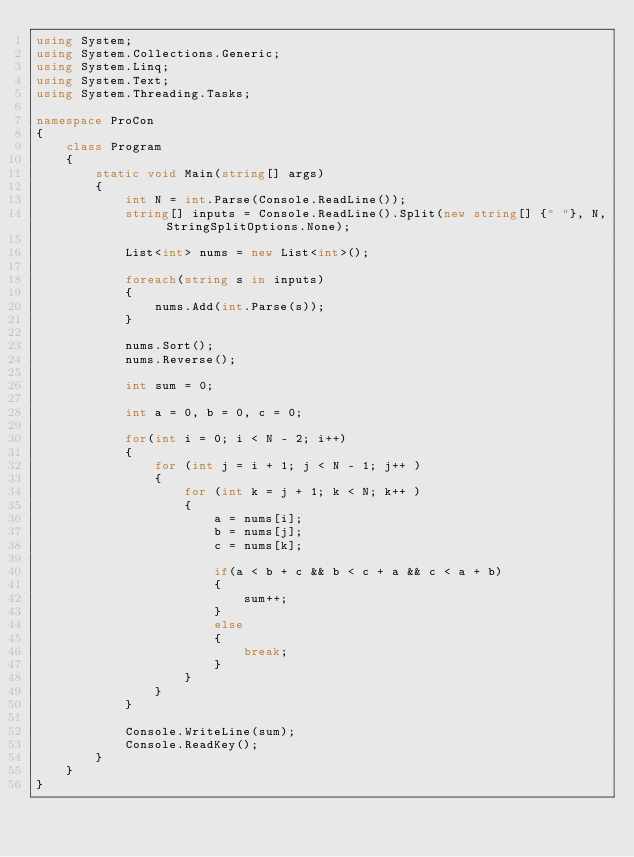Convert code to text. <code><loc_0><loc_0><loc_500><loc_500><_C#_>using System;
using System.Collections.Generic;
using System.Linq;
using System.Text;
using System.Threading.Tasks;

namespace ProCon
{
    class Program
    {
        static void Main(string[] args)
        {
            int N = int.Parse(Console.ReadLine());
            string[] inputs = Console.ReadLine().Split(new string[] {" "}, N, StringSplitOptions.None);

            List<int> nums = new List<int>();

            foreach(string s in inputs)
            {
                nums.Add(int.Parse(s));
            }

            nums.Sort();
            nums.Reverse();

            int sum = 0;

            int a = 0, b = 0, c = 0;

            for(int i = 0; i < N - 2; i++)
            {
                for (int j = i + 1; j < N - 1; j++ )
                {
                    for (int k = j + 1; k < N; k++ )
                    {
                        a = nums[i];
                        b = nums[j];
                        c = nums[k];
                        
                        if(a < b + c && b < c + a && c < a + b)
                        {
                            sum++;
                        }
                        else
                        {
                            break;
                        }
                    }     
                }    
            }

            Console.WriteLine(sum);
            Console.ReadKey();
        }
    }
}
</code> 